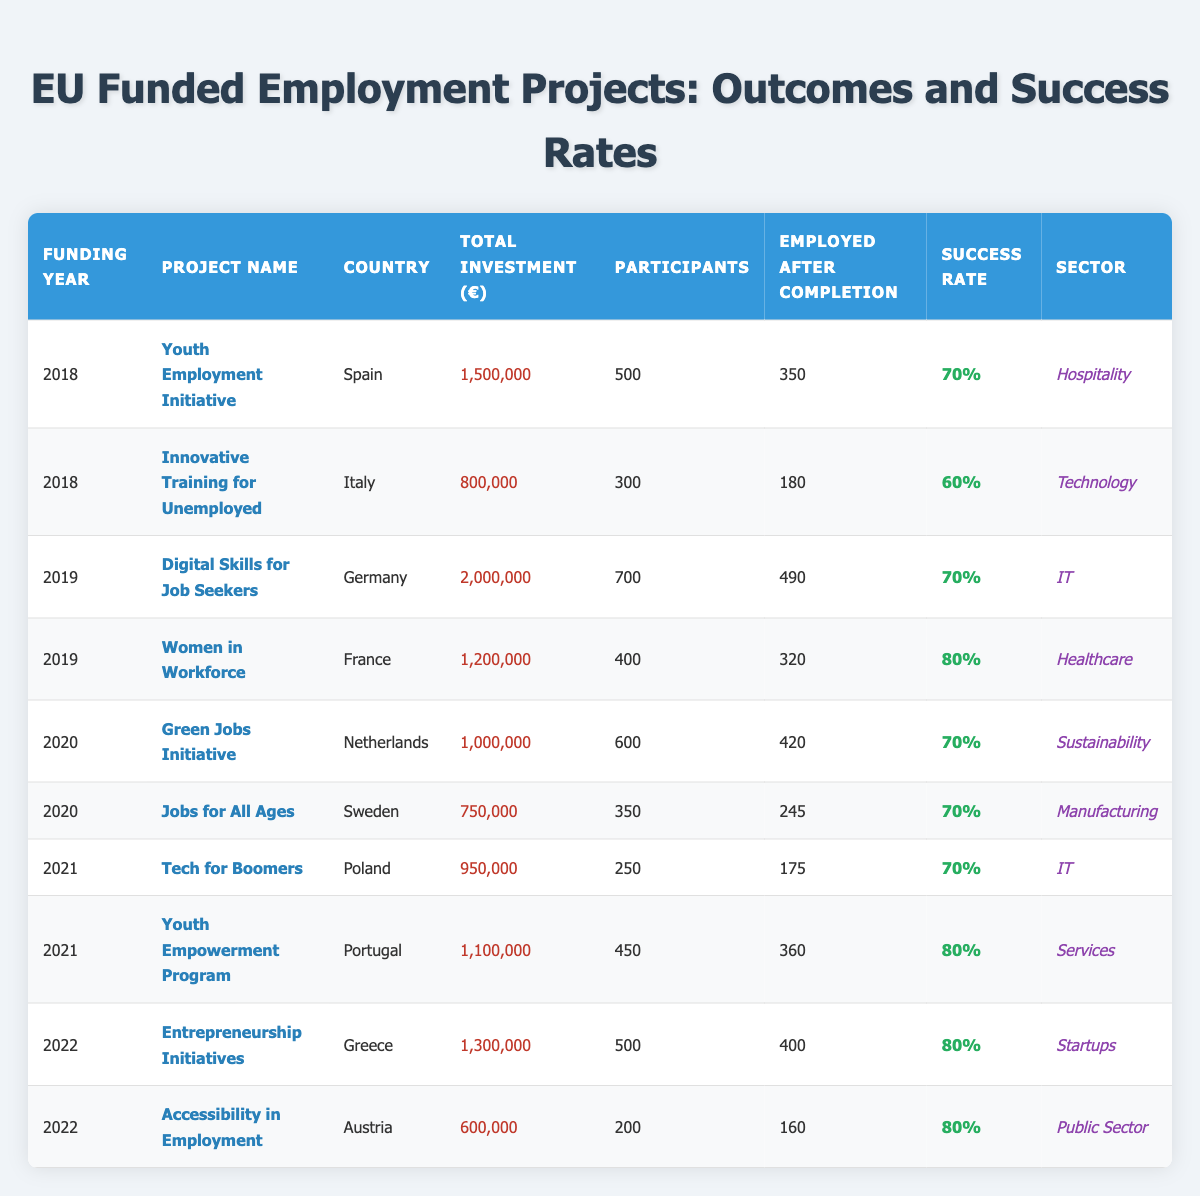What is the success rate of the "Women in Workforce" project? The success rate for the "Women in Workforce" project listed in the table is explicitly shown in the "Success Rate" column next to the relevant project. It is indicated as 80%.
Answer: 80% Which project had the highest total investment and what was that amount? By comparing the "Total Investment" amounts for each project, the "Digital Skills for Job Seekers" project in Germany has the highest total investment of 2,000,000 Euros.
Answer: 2,000,000 Euros How many participants were involved in the "Entrepreneurship Initiatives" project? The number of participants for the "Entrepreneurship Initiatives" project can be found in the "Participants" column next to the corresponding project. It states that there were 500 participants.
Answer: 500 participants What was the success rate of projects funded in 2020? To find the success rate for projects funded in 2020, I look at the success rates listed for each project under that year: the "Green Jobs Initiative" has a 70% success rate and the "Jobs for All Ages" also has a 70%. Both projects have the same rate. Therefore, the average is (70 + 70)/2 = 70%.
Answer: 70% Which country had a project with the lowest success rate and what was the rate? By examining the success rates across all projects, the project with the lowest success rate is the "Innovative Training for Unemployed" from Italy, which achieved a 60% success rate.
Answer: 60% What is the average success rate of all the projects listed? To calculate the average success rate, I sum the success rates from each project: (70 + 60 + 70 + 80 + 70 + 70 + 70 + 80 + 80 + 80) = 800. Then I divide by the number of projects (10), which gives an average of 800/10 = 80%.
Answer: 80% Are there any projects in the IT sector that had a success rate above 70%? Looking through the IT sector projects, there are two listed: "Digital Skills for Job Seekers" with a 70% success rate and "Tech for Boomers" with a 70% success rate, both do not exceed 70%. Therefore, the answer is no.
Answer: No How many projects had success rates of 80% and what are their names? Counting the projects with an 80% success rate, we find three: "Women in Workforce," "Youth Empowerment Program," and "Entrepreneurship Initiatives."
Answer: 3 projects: "Women in Workforce," "Youth Empowerment Program," "Entrepreneurship Initiatives" If we consider only the 2019 projects, what percentage of participants were employed after completion? For 2019, the total number of participants is 700 (Digital Skills for Job Seekers) + 400 (Women in Workforce) = 1100. The employed after completion is 490 (Digital Skills for Job Seekers) + 320 (Women in Workforce) = 810. The employed percentage is (810/1100) * 100 = 73.64%.
Answer: 73.64% What is the difference in success rates between the project with the highest and lowest success rates? The highest success rate is 80% from both "Women in Workforce" and "Entrepreneurship Initiatives" while the lowest is 60% from "Innovative Training for Unemployed." The difference is 80% - 60% = 20%.
Answer: 20% 